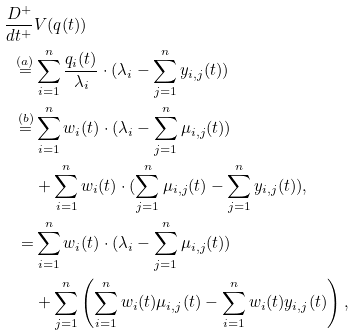Convert formula to latex. <formula><loc_0><loc_0><loc_500><loc_500>\frac { D ^ { + } } { d t ^ { + } } & V ( q ( t ) ) \\ \stackrel { ( a ) } = & \sum _ { i = 1 } ^ { n } \frac { q _ { i } ( t ) } { \lambda _ { i } } \cdot ( \lambda _ { i } - \sum _ { j = 1 } ^ { n } y _ { i , j } ( t ) ) \\ \stackrel { ( b ) } = & \sum _ { i = 1 } ^ { n } w _ { i } ( t ) \cdot ( \lambda _ { i } - \sum _ { j = 1 } ^ { n } \mu _ { i , j } ( t ) ) \\ & + \sum _ { i = 1 } ^ { n } w _ { i } ( t ) \cdot ( \sum _ { j = 1 } ^ { n } \mu _ { i , j } ( t ) - \sum _ { j = 1 } ^ { n } y _ { i , j } ( t ) ) , \\ = & \sum _ { i = 1 } ^ { n } w _ { i } ( t ) \cdot ( \lambda _ { i } - \sum _ { j = 1 } ^ { n } \mu _ { i , j } ( t ) ) \\ & + \sum _ { j = 1 } ^ { n } \left ( \sum _ { i = 1 } ^ { n } w _ { i } ( t ) \mu _ { i , j } ( t ) - \sum _ { i = 1 } ^ { n } w _ { i } ( t ) y _ { i , j } ( t ) \right ) ,</formula> 